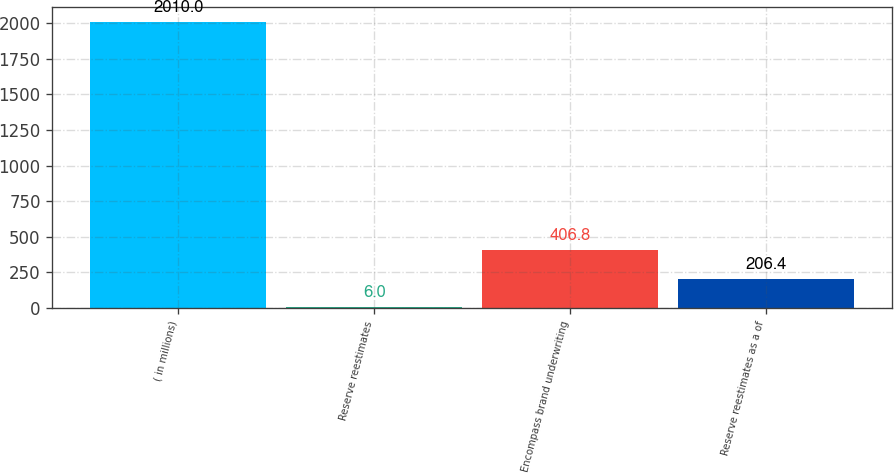Convert chart. <chart><loc_0><loc_0><loc_500><loc_500><bar_chart><fcel>( in millions)<fcel>Reserve reestimates<fcel>Encompass brand underwriting<fcel>Reserve reestimates as a of<nl><fcel>2010<fcel>6<fcel>406.8<fcel>206.4<nl></chart> 